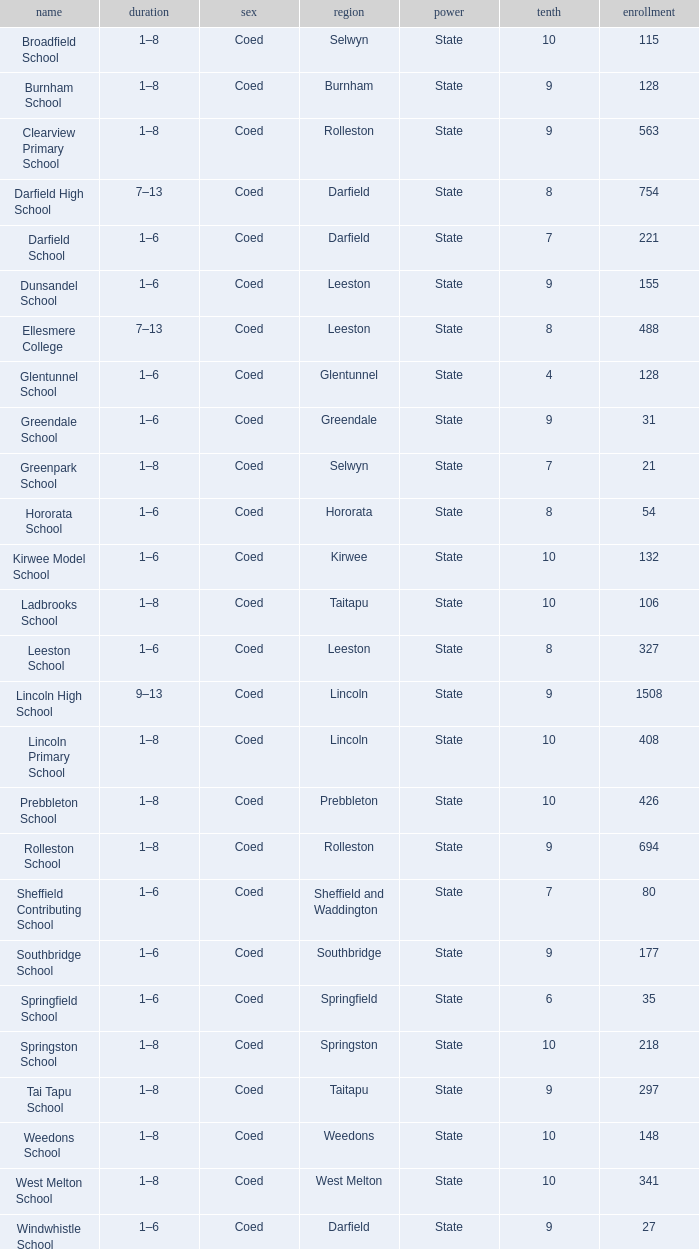Which years have a Name of ladbrooks school? 1–8. 